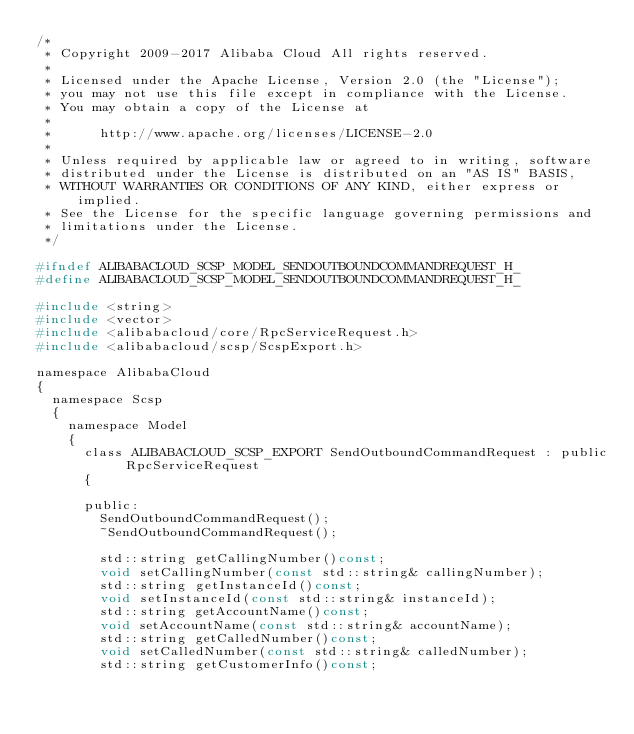Convert code to text. <code><loc_0><loc_0><loc_500><loc_500><_C_>/*
 * Copyright 2009-2017 Alibaba Cloud All rights reserved.
 * 
 * Licensed under the Apache License, Version 2.0 (the "License");
 * you may not use this file except in compliance with the License.
 * You may obtain a copy of the License at
 * 
 *      http://www.apache.org/licenses/LICENSE-2.0
 * 
 * Unless required by applicable law or agreed to in writing, software
 * distributed under the License is distributed on an "AS IS" BASIS,
 * WITHOUT WARRANTIES OR CONDITIONS OF ANY KIND, either express or implied.
 * See the License for the specific language governing permissions and
 * limitations under the License.
 */

#ifndef ALIBABACLOUD_SCSP_MODEL_SENDOUTBOUNDCOMMANDREQUEST_H_
#define ALIBABACLOUD_SCSP_MODEL_SENDOUTBOUNDCOMMANDREQUEST_H_

#include <string>
#include <vector>
#include <alibabacloud/core/RpcServiceRequest.h>
#include <alibabacloud/scsp/ScspExport.h>

namespace AlibabaCloud
{
	namespace Scsp
	{
		namespace Model
		{
			class ALIBABACLOUD_SCSP_EXPORT SendOutboundCommandRequest : public RpcServiceRequest
			{

			public:
				SendOutboundCommandRequest();
				~SendOutboundCommandRequest();

				std::string getCallingNumber()const;
				void setCallingNumber(const std::string& callingNumber);
				std::string getInstanceId()const;
				void setInstanceId(const std::string& instanceId);
				std::string getAccountName()const;
				void setAccountName(const std::string& accountName);
				std::string getCalledNumber()const;
				void setCalledNumber(const std::string& calledNumber);
				std::string getCustomerInfo()const;</code> 